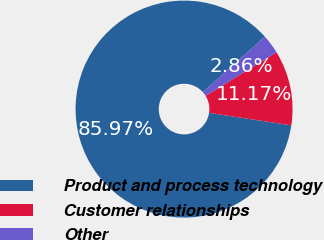<chart> <loc_0><loc_0><loc_500><loc_500><pie_chart><fcel>Product and process technology<fcel>Customer relationships<fcel>Other<nl><fcel>85.98%<fcel>11.17%<fcel>2.86%<nl></chart> 